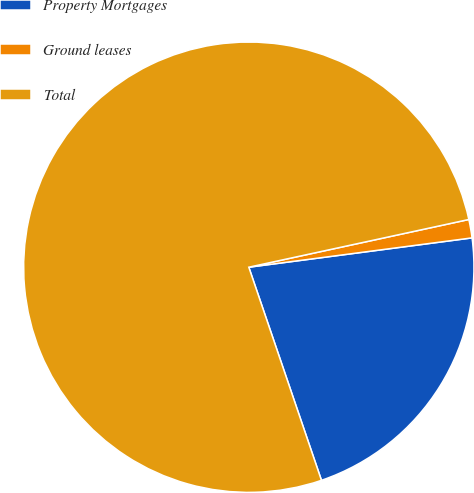Convert chart. <chart><loc_0><loc_0><loc_500><loc_500><pie_chart><fcel>Property Mortgages<fcel>Ground leases<fcel>Total<nl><fcel>21.85%<fcel>1.32%<fcel>76.83%<nl></chart> 